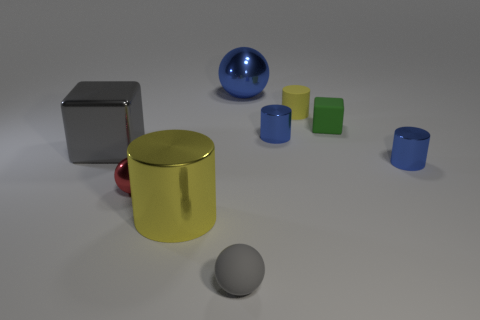There is a gray object that is the same shape as the green matte object; what is it made of? The gray object, which shares its shape with the green matte object, appears to be made of a reflective metal, possibly steel or aluminum, given its lustrous surface and the way it reflects the light in the environment. 